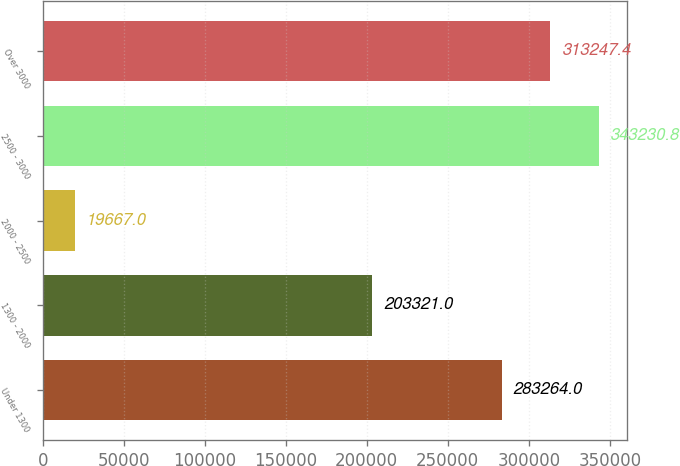<chart> <loc_0><loc_0><loc_500><loc_500><bar_chart><fcel>Under 1300<fcel>1300 - 2000<fcel>2000 - 2500<fcel>2500 - 3000<fcel>Over 3000<nl><fcel>283264<fcel>203321<fcel>19667<fcel>343231<fcel>313247<nl></chart> 